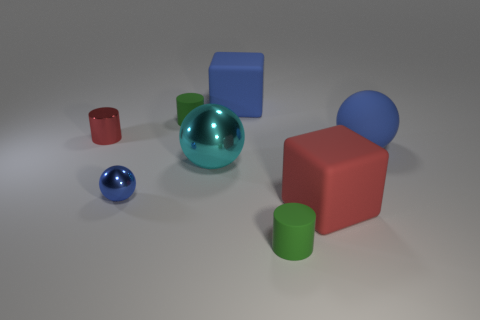How many blue balls must be subtracted to get 1 blue balls? 1 Add 1 small blue cylinders. How many objects exist? 9 Subtract all cylinders. How many objects are left? 5 Subtract all big blue rubber cylinders. Subtract all big cyan things. How many objects are left? 7 Add 6 blue metal things. How many blue metal things are left? 7 Add 8 big cyan shiny balls. How many big cyan shiny balls exist? 9 Subtract 0 purple cylinders. How many objects are left? 8 